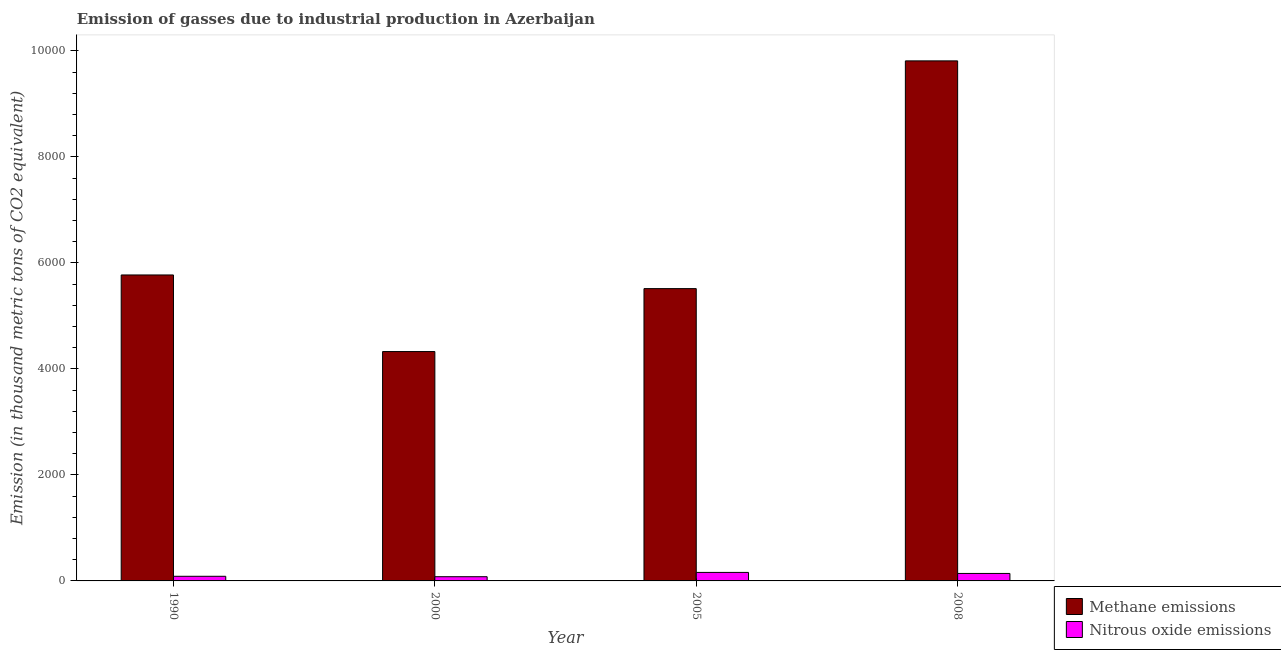How many bars are there on the 2nd tick from the left?
Your response must be concise. 2. What is the label of the 1st group of bars from the left?
Your answer should be compact. 1990. What is the amount of methane emissions in 1990?
Offer a very short reply. 5773. Across all years, what is the maximum amount of nitrous oxide emissions?
Provide a short and direct response. 160.4. Across all years, what is the minimum amount of nitrous oxide emissions?
Your answer should be compact. 79.5. What is the total amount of nitrous oxide emissions in the graph?
Provide a succinct answer. 468.3. What is the difference between the amount of nitrous oxide emissions in 2005 and that in 2008?
Offer a terse response. 19.4. What is the difference between the amount of nitrous oxide emissions in 2005 and the amount of methane emissions in 2008?
Ensure brevity in your answer.  19.4. What is the average amount of nitrous oxide emissions per year?
Offer a terse response. 117.08. What is the ratio of the amount of nitrous oxide emissions in 1990 to that in 2000?
Give a very brief answer. 1.1. Is the amount of methane emissions in 1990 less than that in 2005?
Offer a very short reply. No. Is the difference between the amount of methane emissions in 1990 and 2005 greater than the difference between the amount of nitrous oxide emissions in 1990 and 2005?
Your answer should be very brief. No. What is the difference between the highest and the second highest amount of methane emissions?
Give a very brief answer. 4039.4. What is the difference between the highest and the lowest amount of methane emissions?
Give a very brief answer. 5484.6. What does the 2nd bar from the left in 2008 represents?
Make the answer very short. Nitrous oxide emissions. What does the 2nd bar from the right in 2005 represents?
Provide a short and direct response. Methane emissions. How many bars are there?
Your answer should be very brief. 8. Does the graph contain grids?
Keep it short and to the point. No. How many legend labels are there?
Your answer should be very brief. 2. How are the legend labels stacked?
Provide a short and direct response. Vertical. What is the title of the graph?
Give a very brief answer. Emission of gasses due to industrial production in Azerbaijan. Does "Import" appear as one of the legend labels in the graph?
Ensure brevity in your answer.  No. What is the label or title of the Y-axis?
Your answer should be very brief. Emission (in thousand metric tons of CO2 equivalent). What is the Emission (in thousand metric tons of CO2 equivalent) of Methane emissions in 1990?
Ensure brevity in your answer.  5773. What is the Emission (in thousand metric tons of CO2 equivalent) of Nitrous oxide emissions in 1990?
Offer a very short reply. 87.4. What is the Emission (in thousand metric tons of CO2 equivalent) of Methane emissions in 2000?
Ensure brevity in your answer.  4327.8. What is the Emission (in thousand metric tons of CO2 equivalent) in Nitrous oxide emissions in 2000?
Keep it short and to the point. 79.5. What is the Emission (in thousand metric tons of CO2 equivalent) in Methane emissions in 2005?
Provide a short and direct response. 5515.2. What is the Emission (in thousand metric tons of CO2 equivalent) of Nitrous oxide emissions in 2005?
Give a very brief answer. 160.4. What is the Emission (in thousand metric tons of CO2 equivalent) in Methane emissions in 2008?
Offer a very short reply. 9812.4. What is the Emission (in thousand metric tons of CO2 equivalent) of Nitrous oxide emissions in 2008?
Your response must be concise. 141. Across all years, what is the maximum Emission (in thousand metric tons of CO2 equivalent) in Methane emissions?
Keep it short and to the point. 9812.4. Across all years, what is the maximum Emission (in thousand metric tons of CO2 equivalent) of Nitrous oxide emissions?
Keep it short and to the point. 160.4. Across all years, what is the minimum Emission (in thousand metric tons of CO2 equivalent) in Methane emissions?
Provide a succinct answer. 4327.8. Across all years, what is the minimum Emission (in thousand metric tons of CO2 equivalent) in Nitrous oxide emissions?
Your answer should be very brief. 79.5. What is the total Emission (in thousand metric tons of CO2 equivalent) of Methane emissions in the graph?
Offer a very short reply. 2.54e+04. What is the total Emission (in thousand metric tons of CO2 equivalent) in Nitrous oxide emissions in the graph?
Ensure brevity in your answer.  468.3. What is the difference between the Emission (in thousand metric tons of CO2 equivalent) in Methane emissions in 1990 and that in 2000?
Provide a short and direct response. 1445.2. What is the difference between the Emission (in thousand metric tons of CO2 equivalent) of Nitrous oxide emissions in 1990 and that in 2000?
Provide a short and direct response. 7.9. What is the difference between the Emission (in thousand metric tons of CO2 equivalent) in Methane emissions in 1990 and that in 2005?
Give a very brief answer. 257.8. What is the difference between the Emission (in thousand metric tons of CO2 equivalent) of Nitrous oxide emissions in 1990 and that in 2005?
Your response must be concise. -73. What is the difference between the Emission (in thousand metric tons of CO2 equivalent) in Methane emissions in 1990 and that in 2008?
Keep it short and to the point. -4039.4. What is the difference between the Emission (in thousand metric tons of CO2 equivalent) in Nitrous oxide emissions in 1990 and that in 2008?
Your answer should be very brief. -53.6. What is the difference between the Emission (in thousand metric tons of CO2 equivalent) of Methane emissions in 2000 and that in 2005?
Keep it short and to the point. -1187.4. What is the difference between the Emission (in thousand metric tons of CO2 equivalent) of Nitrous oxide emissions in 2000 and that in 2005?
Your answer should be very brief. -80.9. What is the difference between the Emission (in thousand metric tons of CO2 equivalent) of Methane emissions in 2000 and that in 2008?
Provide a succinct answer. -5484.6. What is the difference between the Emission (in thousand metric tons of CO2 equivalent) in Nitrous oxide emissions in 2000 and that in 2008?
Your answer should be compact. -61.5. What is the difference between the Emission (in thousand metric tons of CO2 equivalent) in Methane emissions in 2005 and that in 2008?
Ensure brevity in your answer.  -4297.2. What is the difference between the Emission (in thousand metric tons of CO2 equivalent) in Nitrous oxide emissions in 2005 and that in 2008?
Offer a terse response. 19.4. What is the difference between the Emission (in thousand metric tons of CO2 equivalent) in Methane emissions in 1990 and the Emission (in thousand metric tons of CO2 equivalent) in Nitrous oxide emissions in 2000?
Make the answer very short. 5693.5. What is the difference between the Emission (in thousand metric tons of CO2 equivalent) of Methane emissions in 1990 and the Emission (in thousand metric tons of CO2 equivalent) of Nitrous oxide emissions in 2005?
Your response must be concise. 5612.6. What is the difference between the Emission (in thousand metric tons of CO2 equivalent) of Methane emissions in 1990 and the Emission (in thousand metric tons of CO2 equivalent) of Nitrous oxide emissions in 2008?
Your answer should be compact. 5632. What is the difference between the Emission (in thousand metric tons of CO2 equivalent) in Methane emissions in 2000 and the Emission (in thousand metric tons of CO2 equivalent) in Nitrous oxide emissions in 2005?
Keep it short and to the point. 4167.4. What is the difference between the Emission (in thousand metric tons of CO2 equivalent) in Methane emissions in 2000 and the Emission (in thousand metric tons of CO2 equivalent) in Nitrous oxide emissions in 2008?
Keep it short and to the point. 4186.8. What is the difference between the Emission (in thousand metric tons of CO2 equivalent) of Methane emissions in 2005 and the Emission (in thousand metric tons of CO2 equivalent) of Nitrous oxide emissions in 2008?
Offer a terse response. 5374.2. What is the average Emission (in thousand metric tons of CO2 equivalent) of Methane emissions per year?
Keep it short and to the point. 6357.1. What is the average Emission (in thousand metric tons of CO2 equivalent) in Nitrous oxide emissions per year?
Make the answer very short. 117.08. In the year 1990, what is the difference between the Emission (in thousand metric tons of CO2 equivalent) in Methane emissions and Emission (in thousand metric tons of CO2 equivalent) in Nitrous oxide emissions?
Your response must be concise. 5685.6. In the year 2000, what is the difference between the Emission (in thousand metric tons of CO2 equivalent) of Methane emissions and Emission (in thousand metric tons of CO2 equivalent) of Nitrous oxide emissions?
Provide a succinct answer. 4248.3. In the year 2005, what is the difference between the Emission (in thousand metric tons of CO2 equivalent) of Methane emissions and Emission (in thousand metric tons of CO2 equivalent) of Nitrous oxide emissions?
Offer a terse response. 5354.8. In the year 2008, what is the difference between the Emission (in thousand metric tons of CO2 equivalent) of Methane emissions and Emission (in thousand metric tons of CO2 equivalent) of Nitrous oxide emissions?
Offer a terse response. 9671.4. What is the ratio of the Emission (in thousand metric tons of CO2 equivalent) in Methane emissions in 1990 to that in 2000?
Offer a very short reply. 1.33. What is the ratio of the Emission (in thousand metric tons of CO2 equivalent) of Nitrous oxide emissions in 1990 to that in 2000?
Give a very brief answer. 1.1. What is the ratio of the Emission (in thousand metric tons of CO2 equivalent) in Methane emissions in 1990 to that in 2005?
Offer a very short reply. 1.05. What is the ratio of the Emission (in thousand metric tons of CO2 equivalent) in Nitrous oxide emissions in 1990 to that in 2005?
Provide a succinct answer. 0.54. What is the ratio of the Emission (in thousand metric tons of CO2 equivalent) of Methane emissions in 1990 to that in 2008?
Give a very brief answer. 0.59. What is the ratio of the Emission (in thousand metric tons of CO2 equivalent) in Nitrous oxide emissions in 1990 to that in 2008?
Keep it short and to the point. 0.62. What is the ratio of the Emission (in thousand metric tons of CO2 equivalent) of Methane emissions in 2000 to that in 2005?
Keep it short and to the point. 0.78. What is the ratio of the Emission (in thousand metric tons of CO2 equivalent) in Nitrous oxide emissions in 2000 to that in 2005?
Your answer should be compact. 0.5. What is the ratio of the Emission (in thousand metric tons of CO2 equivalent) in Methane emissions in 2000 to that in 2008?
Your response must be concise. 0.44. What is the ratio of the Emission (in thousand metric tons of CO2 equivalent) of Nitrous oxide emissions in 2000 to that in 2008?
Provide a succinct answer. 0.56. What is the ratio of the Emission (in thousand metric tons of CO2 equivalent) in Methane emissions in 2005 to that in 2008?
Make the answer very short. 0.56. What is the ratio of the Emission (in thousand metric tons of CO2 equivalent) of Nitrous oxide emissions in 2005 to that in 2008?
Provide a succinct answer. 1.14. What is the difference between the highest and the second highest Emission (in thousand metric tons of CO2 equivalent) in Methane emissions?
Your answer should be compact. 4039.4. What is the difference between the highest and the lowest Emission (in thousand metric tons of CO2 equivalent) in Methane emissions?
Your answer should be compact. 5484.6. What is the difference between the highest and the lowest Emission (in thousand metric tons of CO2 equivalent) of Nitrous oxide emissions?
Make the answer very short. 80.9. 